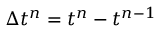<formula> <loc_0><loc_0><loc_500><loc_500>\Delta t ^ { n } = t ^ { n } - t ^ { n - 1 }</formula> 